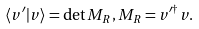Convert formula to latex. <formula><loc_0><loc_0><loc_500><loc_500>\langle v ^ { \prime } | v \rangle = \det M _ { R } , M _ { R } = v ^ { \prime \dagger } v .</formula> 